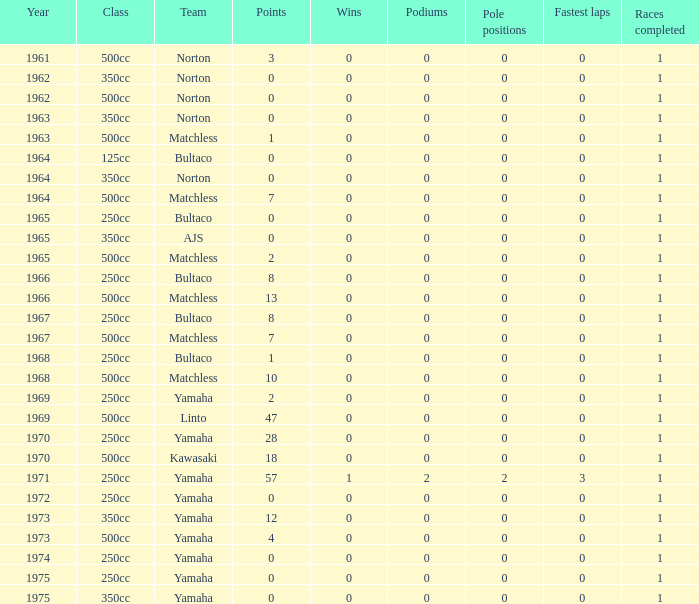What is the average wins in 250cc class for Bultaco with 8 points later than 1966? 0.0. 